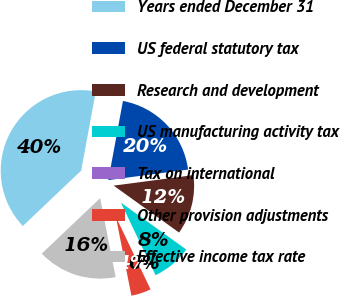<chart> <loc_0><loc_0><loc_500><loc_500><pie_chart><fcel>Years ended December 31<fcel>US federal statutory tax<fcel>Research and development<fcel>US manufacturing activity tax<fcel>Tax on international<fcel>Other provision adjustments<fcel>Effective income tax rate<nl><fcel>40.0%<fcel>20.0%<fcel>12.0%<fcel>8.0%<fcel>0.0%<fcel>4.0%<fcel>16.0%<nl></chart> 